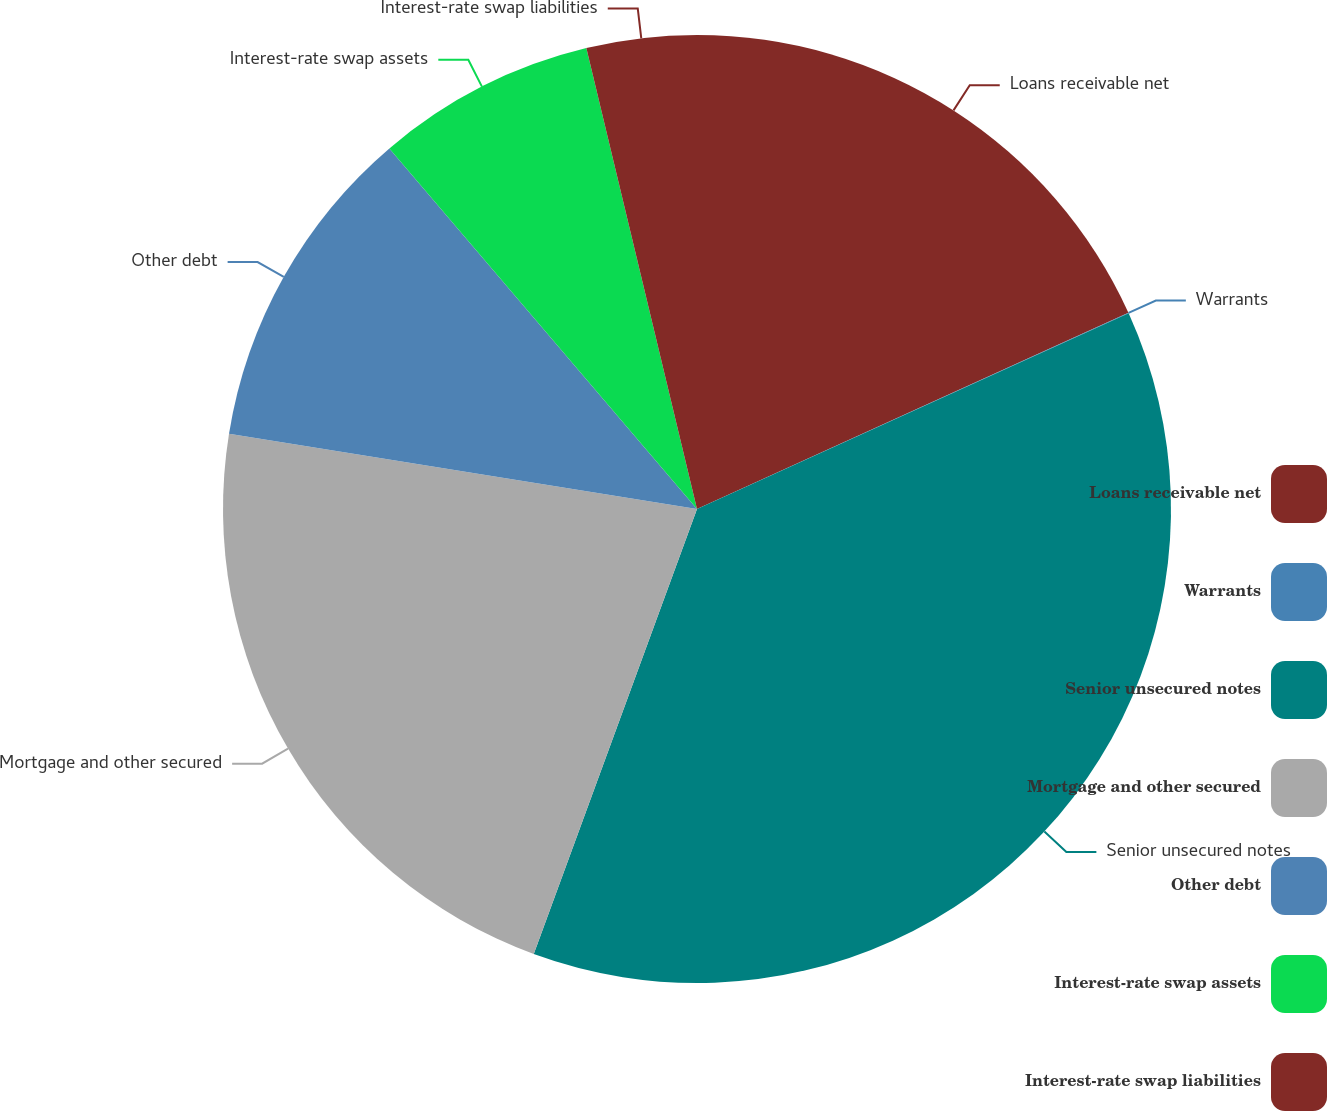Convert chart. <chart><loc_0><loc_0><loc_500><loc_500><pie_chart><fcel>Loans receivable net<fcel>Warrants<fcel>Senior unsecured notes<fcel>Mortgage and other secured<fcel>Other debt<fcel>Interest-rate swap assets<fcel>Interest-rate swap liabilities<nl><fcel>18.2%<fcel>0.02%<fcel>37.37%<fcel>21.94%<fcel>11.22%<fcel>7.49%<fcel>3.75%<nl></chart> 